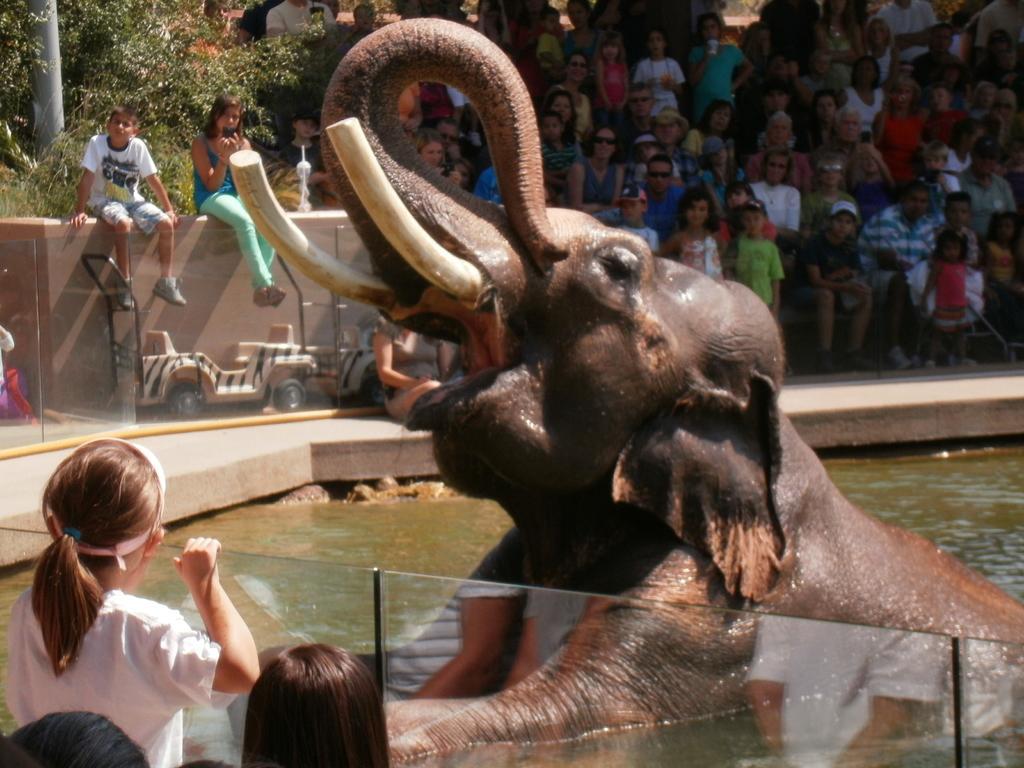Describe this image in one or two sentences. There is an elephant opened her mouth in water and there are audience on the either side watching it. 